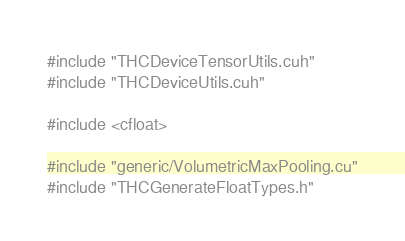<code> <loc_0><loc_0><loc_500><loc_500><_Cuda_>#include "THCDeviceTensorUtils.cuh"
#include "THCDeviceUtils.cuh"

#include <cfloat>

#include "generic/VolumetricMaxPooling.cu"
#include "THCGenerateFloatTypes.h"
</code> 